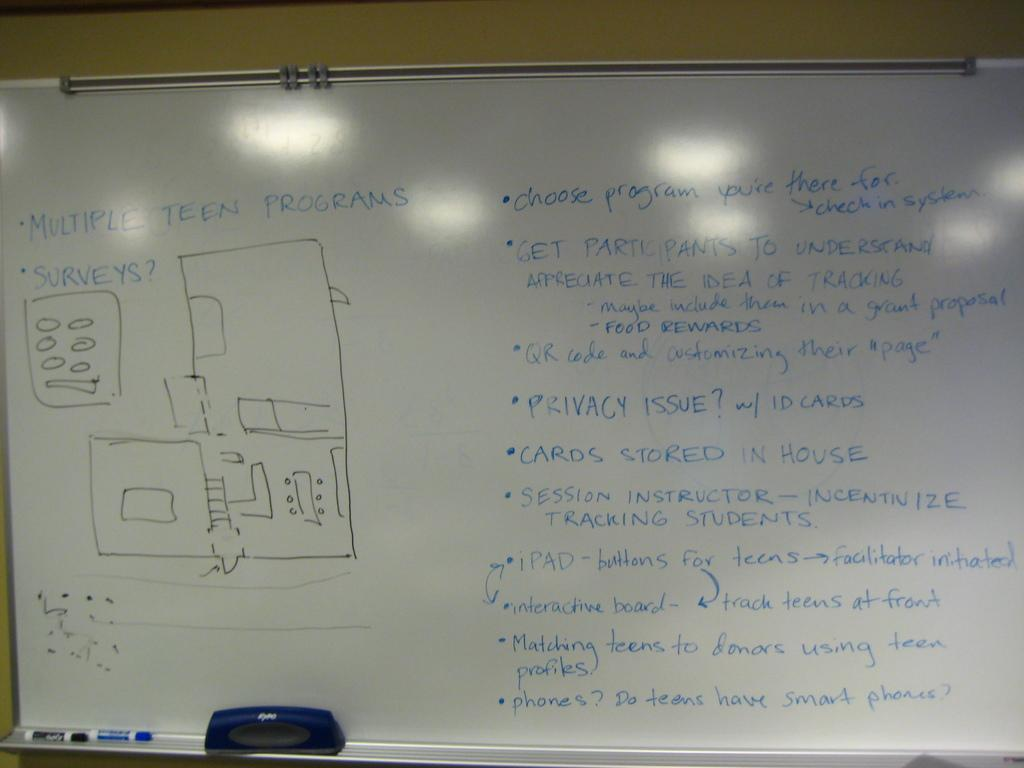Provide a one-sentence caption for the provided image. A white board with a few diagrams and writing on "Multiple Teen Programs" in order to get students to participate in tracking. 